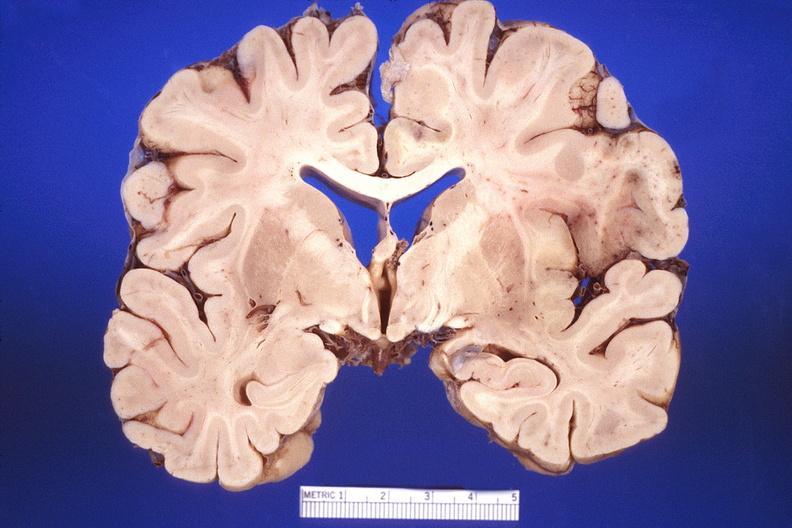what is present?
Answer the question using a single word or phrase. Nervous 